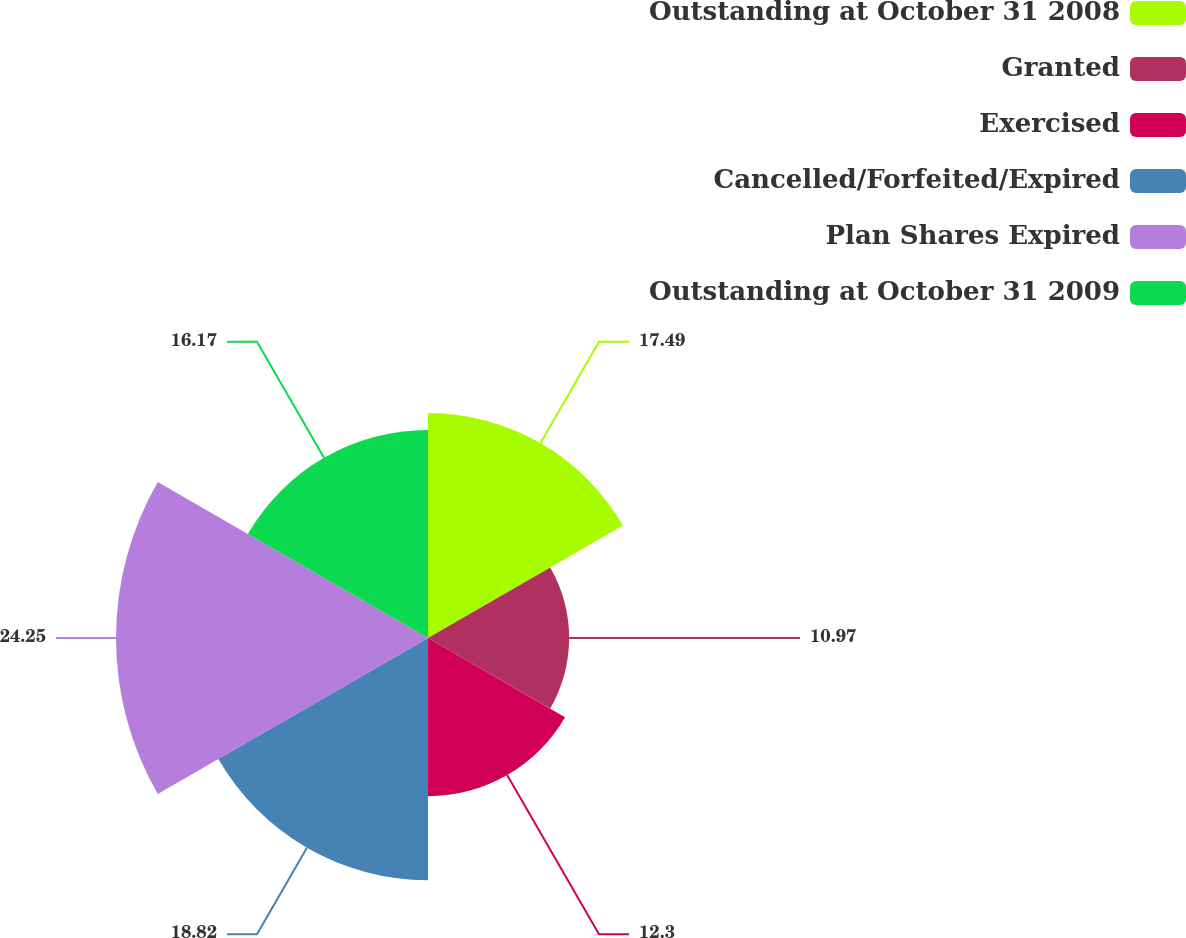<chart> <loc_0><loc_0><loc_500><loc_500><pie_chart><fcel>Outstanding at October 31 2008<fcel>Granted<fcel>Exercised<fcel>Cancelled/Forfeited/Expired<fcel>Plan Shares Expired<fcel>Outstanding at October 31 2009<nl><fcel>17.49%<fcel>10.97%<fcel>12.3%<fcel>18.82%<fcel>24.25%<fcel>16.17%<nl></chart> 